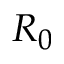Convert formula to latex. <formula><loc_0><loc_0><loc_500><loc_500>R _ { 0 }</formula> 